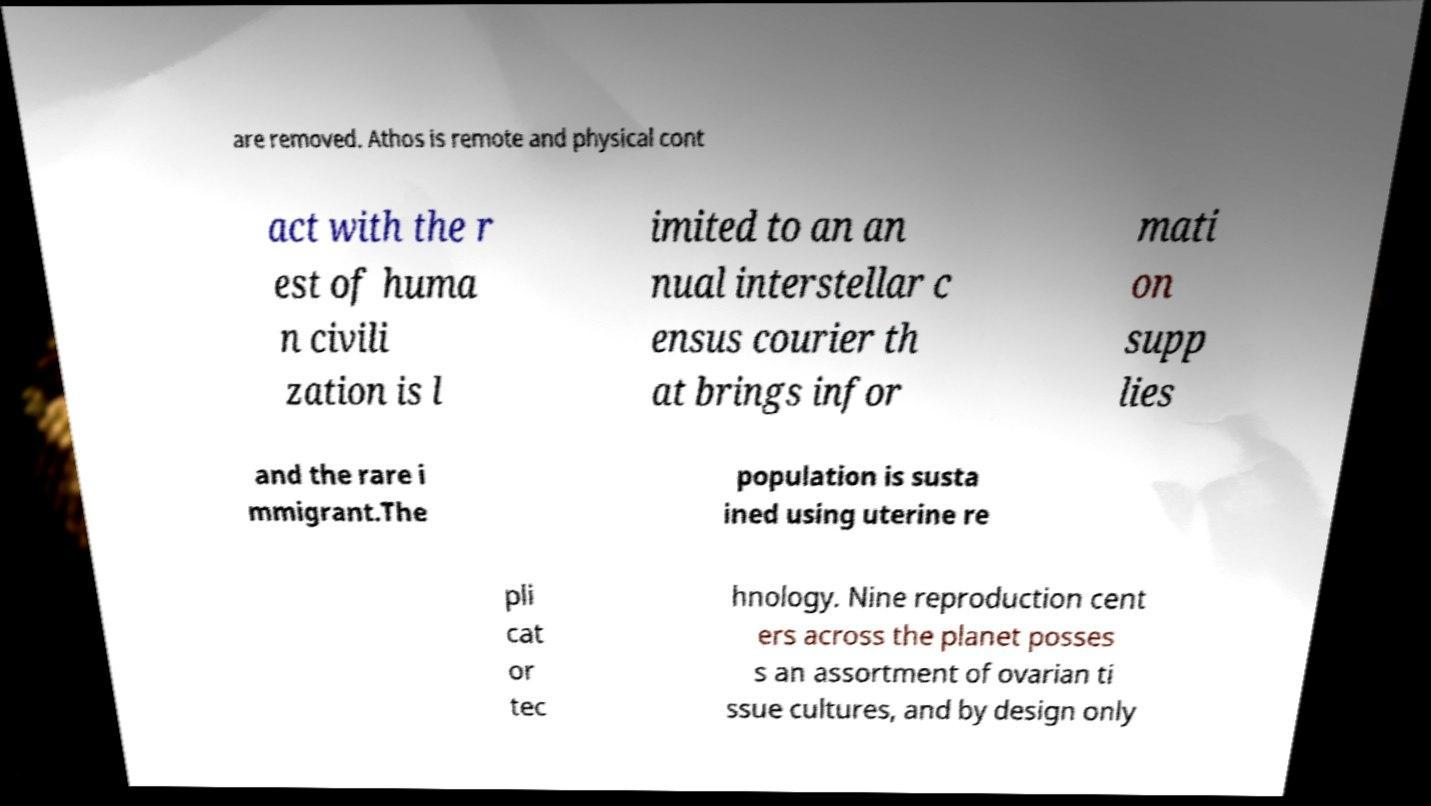Can you accurately transcribe the text from the provided image for me? are removed. Athos is remote and physical cont act with the r est of huma n civili zation is l imited to an an nual interstellar c ensus courier th at brings infor mati on supp lies and the rare i mmigrant.The population is susta ined using uterine re pli cat or tec hnology. Nine reproduction cent ers across the planet posses s an assortment of ovarian ti ssue cultures, and by design only 